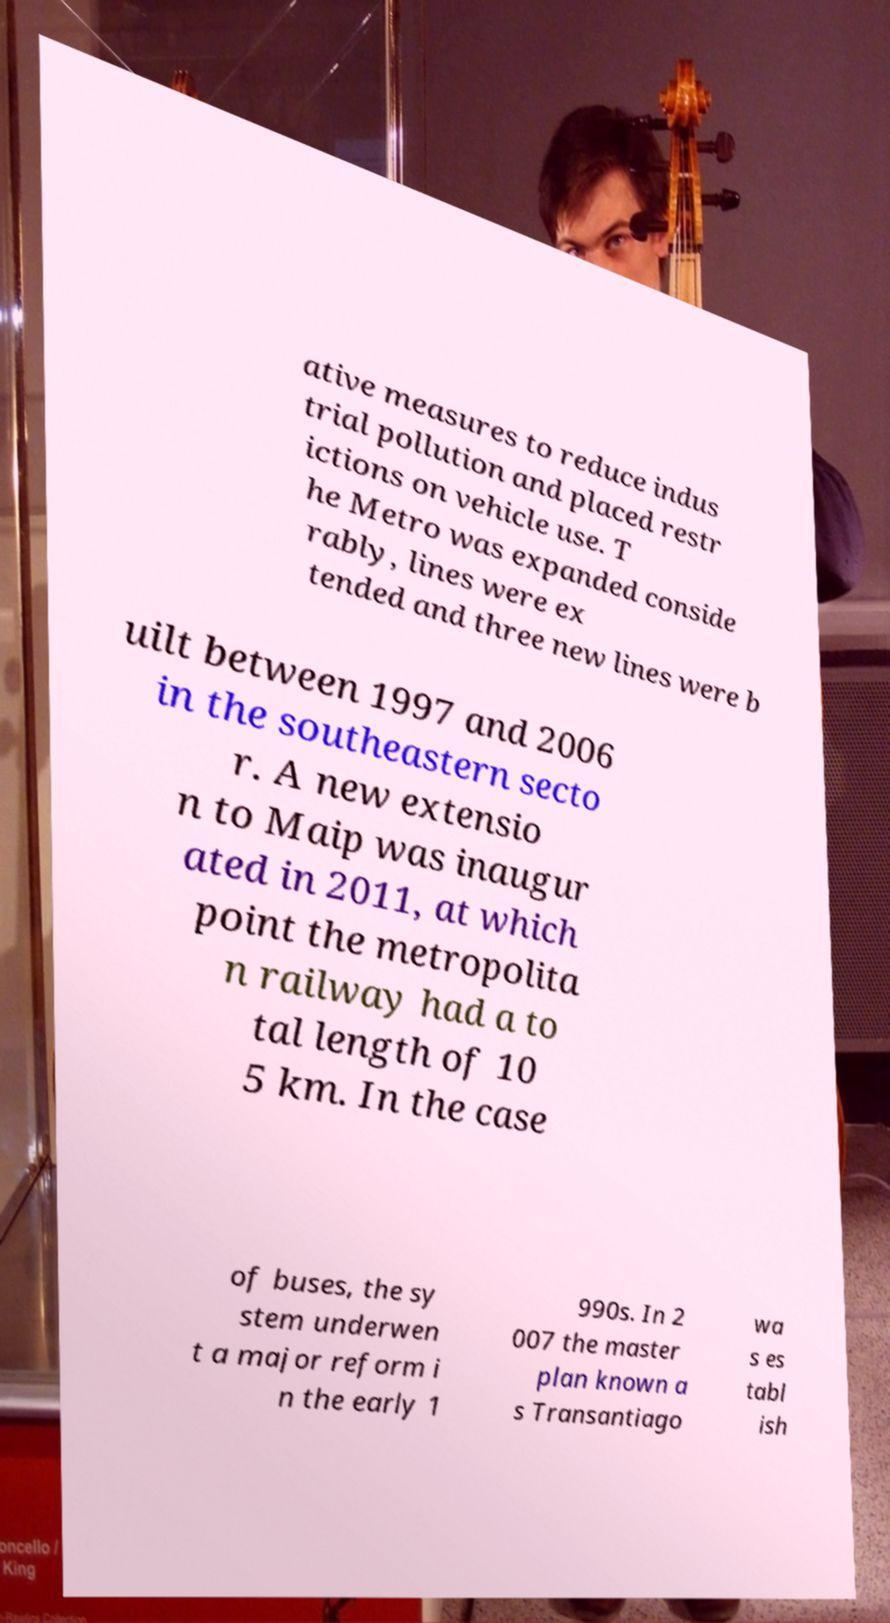What messages or text are displayed in this image? I need them in a readable, typed format. ative measures to reduce indus trial pollution and placed restr ictions on vehicle use. T he Metro was expanded conside rably, lines were ex tended and three new lines were b uilt between 1997 and 2006 in the southeastern secto r. A new extensio n to Maip was inaugur ated in 2011, at which point the metropolita n railway had a to tal length of 10 5 km. In the case of buses, the sy stem underwen t a major reform i n the early 1 990s. In 2 007 the master plan known a s Transantiago wa s es tabl ish 